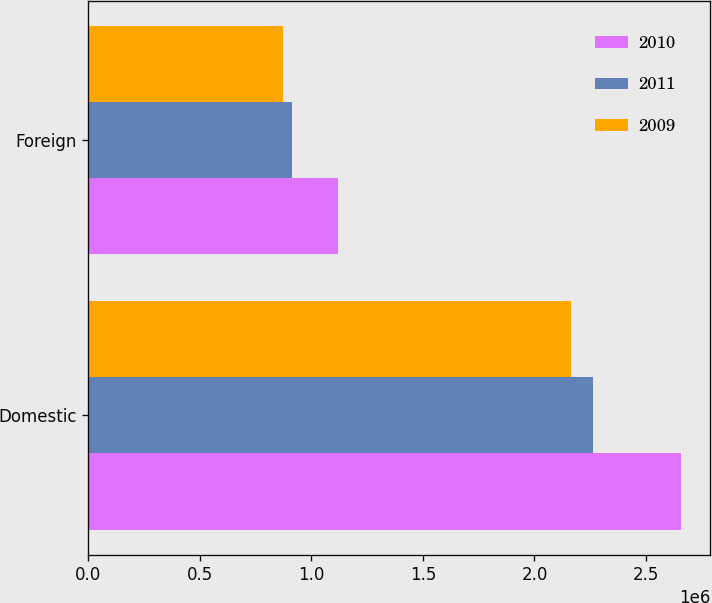Convert chart. <chart><loc_0><loc_0><loc_500><loc_500><stacked_bar_chart><ecel><fcel>Domestic<fcel>Foreign<nl><fcel>2010<fcel>2.65544e+06<fcel>1.12153e+06<nl><fcel>2011<fcel>2.26332e+06<fcel>911777<nl><fcel>2009<fcel>2.16183e+06<fcel>874721<nl></chart> 